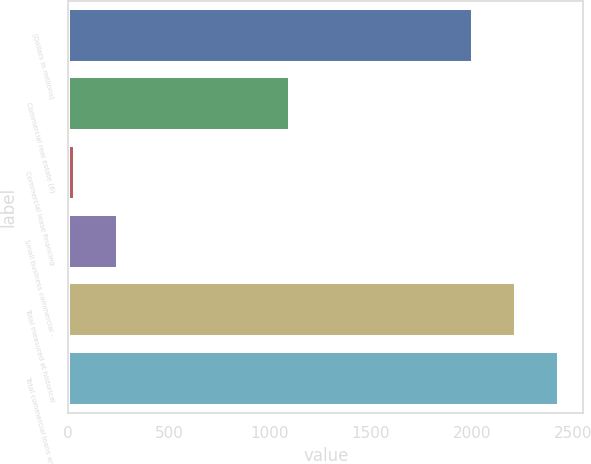<chart> <loc_0><loc_0><loc_500><loc_500><bar_chart><fcel>(Dollars in millions)<fcel>Commercial real estate (6)<fcel>Commercial lease financing<fcel>Small business commercial -<fcel>Total measured at historical<fcel>Total commercial loans and<nl><fcel>2007<fcel>1099<fcel>33<fcel>245.2<fcel>2219.2<fcel>2431.4<nl></chart> 